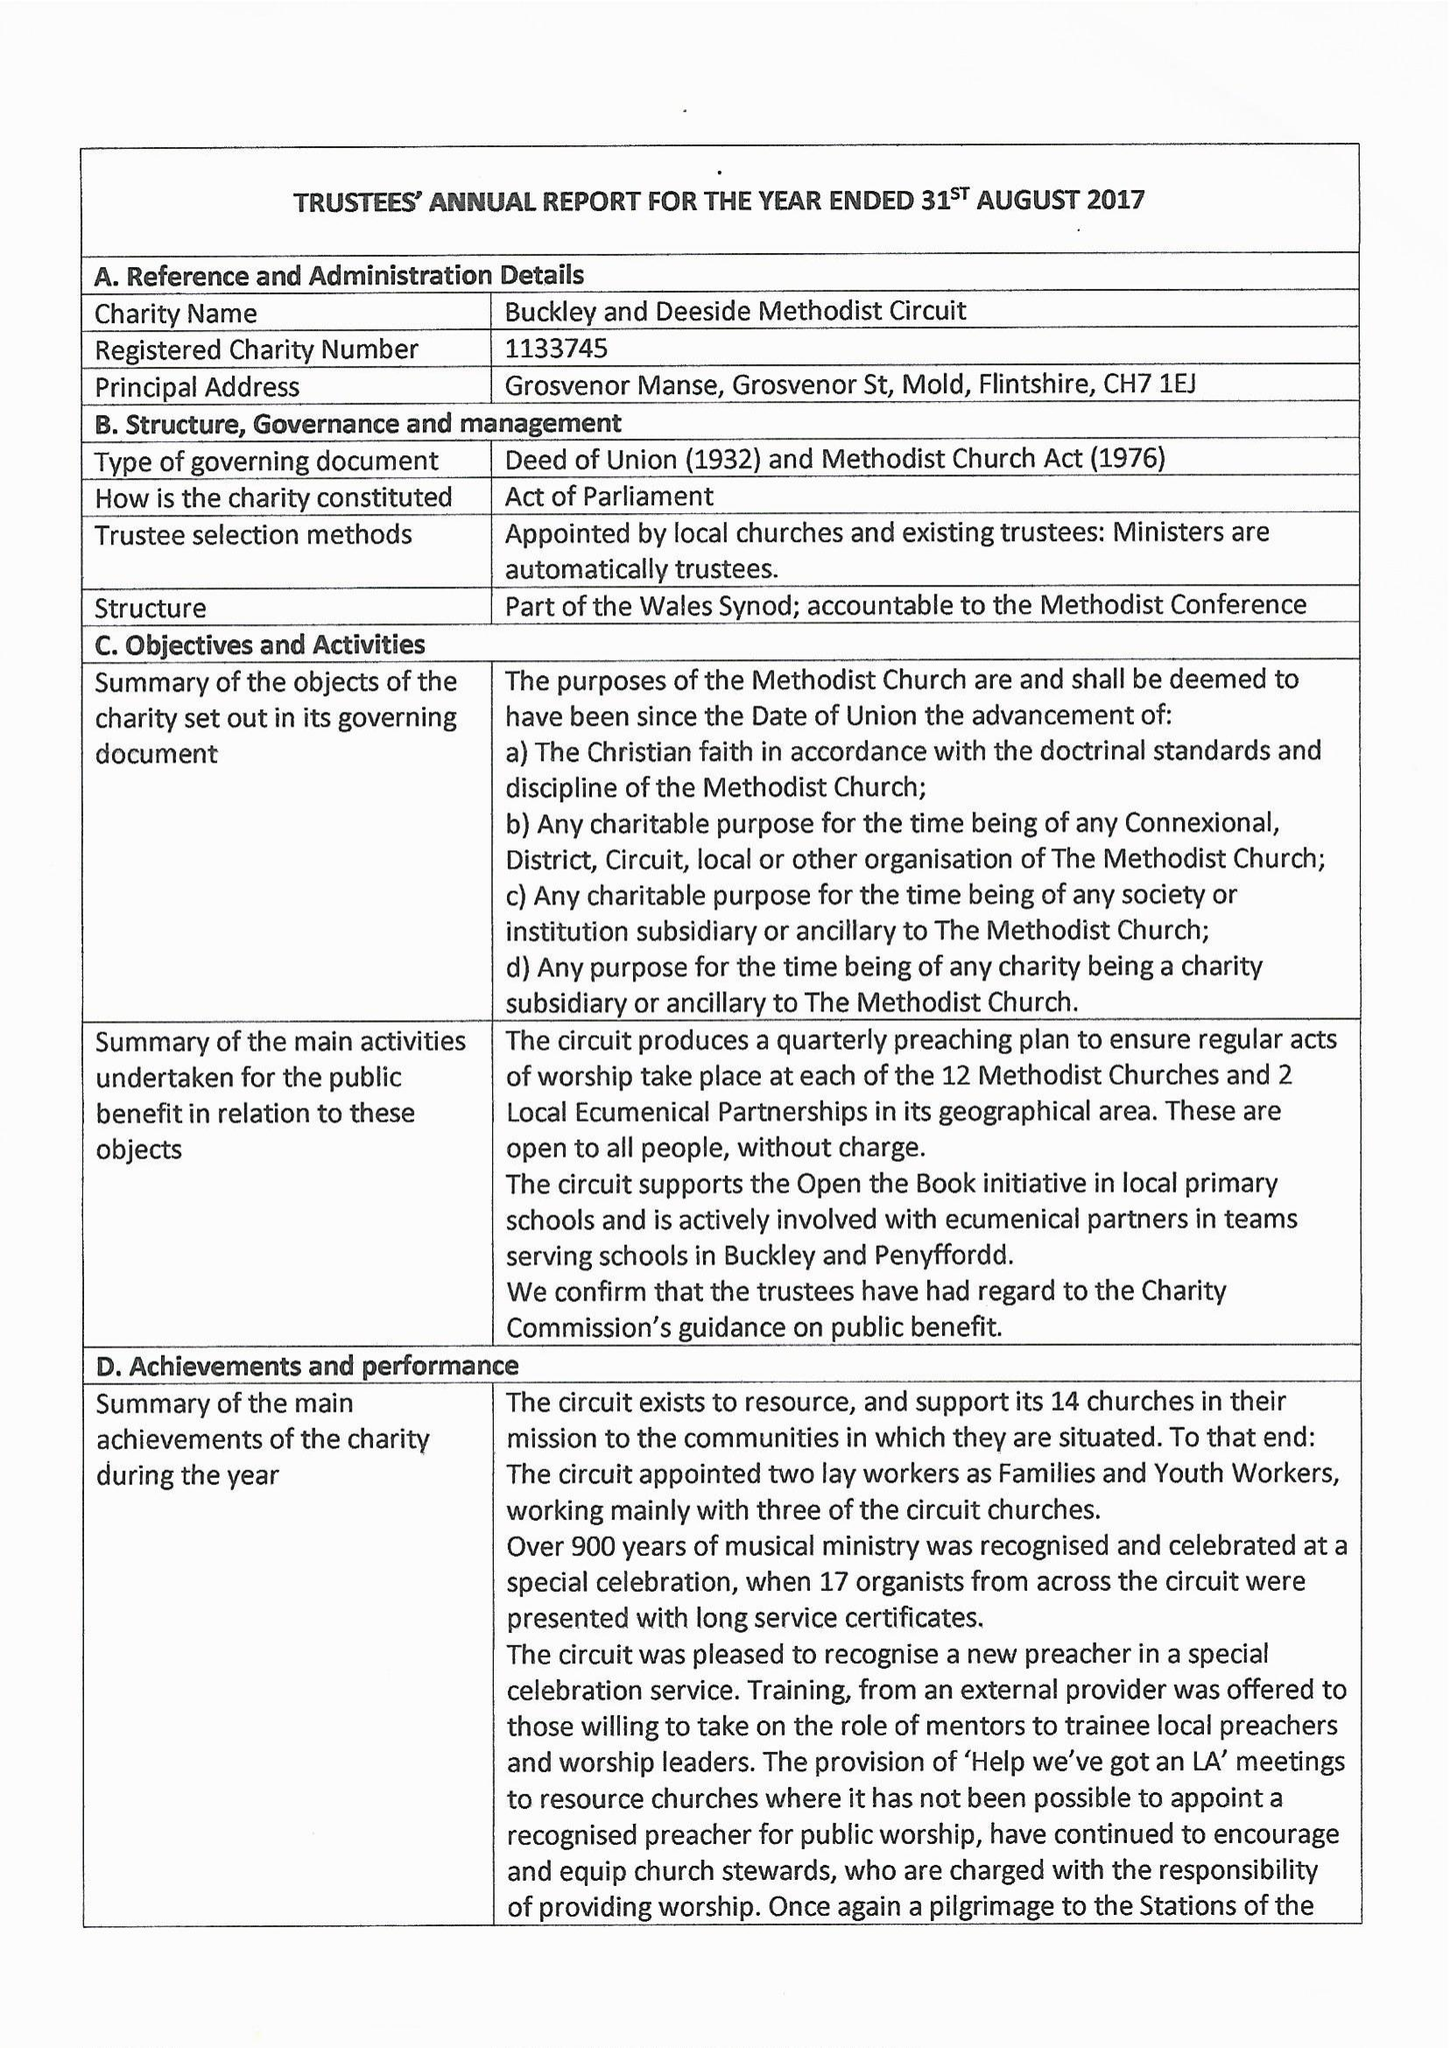What is the value for the spending_annually_in_british_pounds?
Answer the question using a single word or phrase. 194115.00 